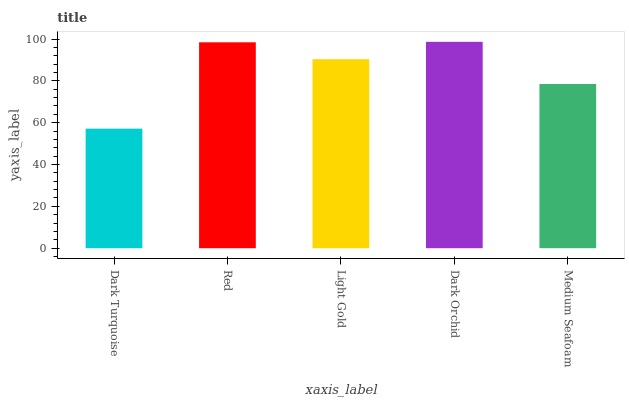Is Red the minimum?
Answer yes or no. No. Is Red the maximum?
Answer yes or no. No. Is Red greater than Dark Turquoise?
Answer yes or no. Yes. Is Dark Turquoise less than Red?
Answer yes or no. Yes. Is Dark Turquoise greater than Red?
Answer yes or no. No. Is Red less than Dark Turquoise?
Answer yes or no. No. Is Light Gold the high median?
Answer yes or no. Yes. Is Light Gold the low median?
Answer yes or no. Yes. Is Red the high median?
Answer yes or no. No. Is Dark Orchid the low median?
Answer yes or no. No. 